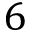<formula> <loc_0><loc_0><loc_500><loc_500>6</formula> 